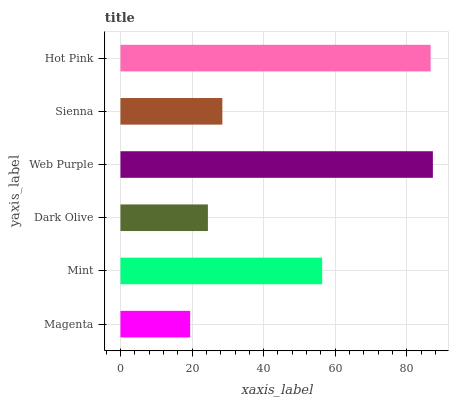Is Magenta the minimum?
Answer yes or no. Yes. Is Web Purple the maximum?
Answer yes or no. Yes. Is Mint the minimum?
Answer yes or no. No. Is Mint the maximum?
Answer yes or no. No. Is Mint greater than Magenta?
Answer yes or no. Yes. Is Magenta less than Mint?
Answer yes or no. Yes. Is Magenta greater than Mint?
Answer yes or no. No. Is Mint less than Magenta?
Answer yes or no. No. Is Mint the high median?
Answer yes or no. Yes. Is Sienna the low median?
Answer yes or no. Yes. Is Sienna the high median?
Answer yes or no. No. Is Hot Pink the low median?
Answer yes or no. No. 